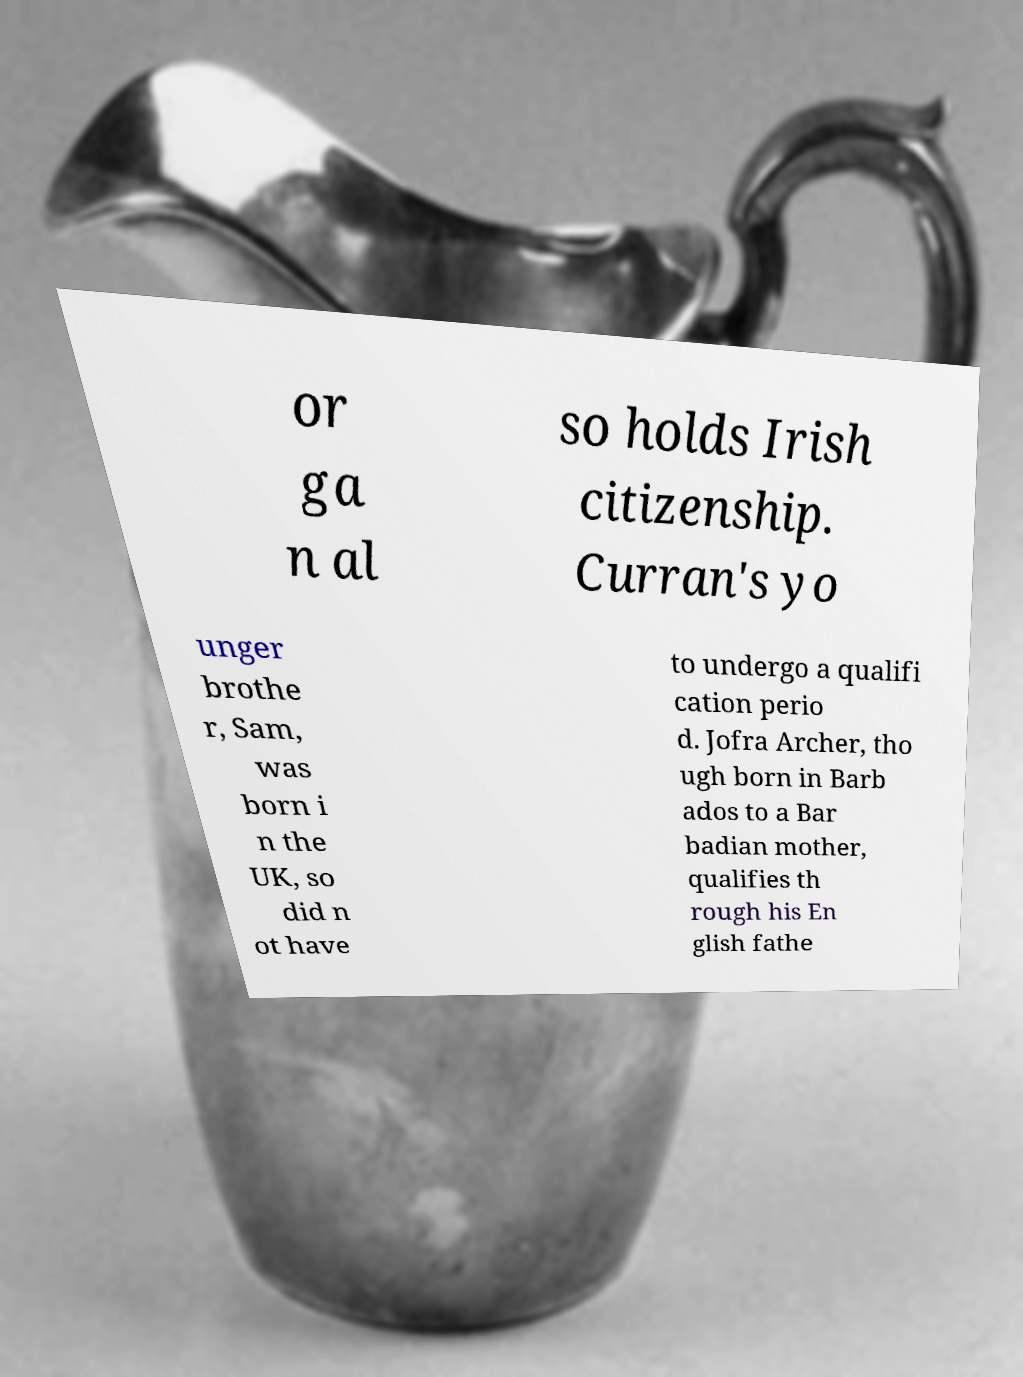Could you extract and type out the text from this image? or ga n al so holds Irish citizenship. Curran's yo unger brothe r, Sam, was born i n the UK, so did n ot have to undergo a qualifi cation perio d. Jofra Archer, tho ugh born in Barb ados to a Bar badian mother, qualifies th rough his En glish fathe 